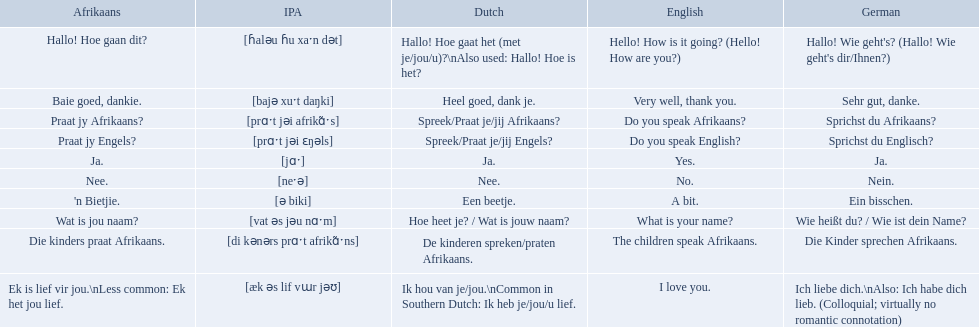What are the afrikaans phrases? Hallo! Hoe gaan dit?, Baie goed, dankie., Praat jy Afrikaans?, Praat jy Engels?, Ja., Nee., 'n Bietjie., Wat is jou naam?, Die kinders praat Afrikaans., Ek is lief vir jou.\nLess common: Ek het jou lief. For die kinders praat afrikaans, what are the translations? De kinderen spreken/praten Afrikaans., The children speak Afrikaans., Die Kinder sprechen Afrikaans. Which one is the german translation? Die Kinder sprechen Afrikaans. What are the listed afrikaans phrases? Hallo! Hoe gaan dit?, Baie goed, dankie., Praat jy Afrikaans?, Praat jy Engels?, Ja., Nee., 'n Bietjie., Wat is jou naam?, Die kinders praat Afrikaans., Ek is lief vir jou.\nLess common: Ek het jou lief. Which is die kinders praat afrikaans? Die kinders praat Afrikaans. What is its german translation? Die Kinder sprechen Afrikaans. In german how do you say do you speak afrikaans? Sprichst du Afrikaans?. How do you say it in afrikaans? Praat jy Afrikaans?. What are all of the afrikaans phrases shown in the table? Hallo! Hoe gaan dit?, Baie goed, dankie., Praat jy Afrikaans?, Praat jy Engels?, Ja., Nee., 'n Bietjie., Wat is jou naam?, Die kinders praat Afrikaans., Ek is lief vir jou.\nLess common: Ek het jou lief. Of those, which translates into english as do you speak afrikaans?? Praat jy Afrikaans?. How do you say hello! how is it going? in afrikaans? Hallo! Hoe gaan dit?. How do you say very well, thank you in afrikaans? Baie goed, dankie. How would you say do you speak afrikaans? in afrikaans? Praat jy Afrikaans?. Which phrases are said in africaans? Hallo! Hoe gaan dit?, Baie goed, dankie., Praat jy Afrikaans?, Praat jy Engels?, Ja., Nee., 'n Bietjie., Wat is jou naam?, Die kinders praat Afrikaans., Ek is lief vir jou.\nLess common: Ek het jou lief. Which of these mean how do you speak afrikaans? Praat jy Afrikaans?. How do you articulate "do you speak afrikaans? Sprichst du Afrikaans?. " in german and how is it communicated in afrikaans? Praat jy Afrikaans?. What phrases are uttered in afrikaans? Hallo! Hoe gaan dit?, Baie goed, dankie., Praat jy Afrikaans?, Praat jy Engels?, Ja., Nee., 'n Bietjie., Wat is jou naam?, Die kinders praat Afrikaans., Ek is lief vir jou.\nLess common: Ek het jou lief. Which among these imply how to converse in afrikaans? Praat jy Afrikaans?. What are the itemized afrikaans sayings? Hallo! Hoe gaan dit?, Baie goed, dankie., Praat jy Afrikaans?, Praat jy Engels?, Ja., Nee., 'n Bietjie., Wat is jou naam?, Die kinders praat Afrikaans., Ek is lief vir jou.\nLess common: Ek het jou lief. Which one aligns with "die kinders praat afrikaans"? Die kinders praat Afrikaans. What is its german rendition? Die Kinder sprechen Afrikaans. How can you express the sentence "the children speak afrikaans" in afrikaans? Die kinders praat Afrikaans. How can you express the aforementioned sentence in german? Die Kinder sprechen Afrikaans. How do you convey "do you speak afrikaans? Sprichst du Afrikaans?. " in german, and what is the afrikaans phrase for it? Praat jy Afrikaans?. How can you convey "do you speak english" in german? Sprichst du Englisch?. Additionally, how to communicate "do you speak afrikaans" in afrikaans? Praat jy Afrikaans?. How do you phrase "do you speak english" in german? Sprichst du Englisch?. Moreover, how to articulate "do you speak afrikaans" in afrikaans? Praat jy Afrikaans?. What afrikaans phrases exist? Hallo! Hoe gaan dit?, Baie goed, dankie., Praat jy Afrikaans?, Praat jy Engels?, Ja., Nee., 'n Bietjie., Wat is jou naam?, Die kinders praat Afrikaans., Ek is lief vir jou.\nLess common: Ek het jou lief. Regarding "die kinders praat afrikaans," what translations can be provided? De kinderen spreken/praten Afrikaans., The children speak Afrikaans., Die Kinder sprechen Afrikaans. Which translation is in german? Die Kinder sprechen Afrikaans. What are the given afrikaans sayings? Hallo! Hoe gaan dit?, Baie goed, dankie., Praat jy Afrikaans?, Praat jy Engels?, Ja., Nee., 'n Bietjie., Wat is jou naam?, Die kinders praat Afrikaans., Ek is lief vir jou.\nLess common: Ek het jou lief. Which one means "die kinders praat afrikaans"? Die kinders praat Afrikaans. What is this phrase translated to in german? Die Kinder sprechen Afrikaans. What afrikaans phrases are provided? Hallo! Hoe gaan dit?, Baie goed, dankie., Praat jy Afrikaans?, Praat jy Engels?, Ja., Nee., 'n Bietjie., Wat is jou naam?, Die kinders praat Afrikaans., Ek is lief vir jou.\nLess common: Ek het jou lief. Which one corresponds to "die kinders praat afrikaans"? Die kinders praat Afrikaans. What would be its translation in german? Die Kinder sprechen Afrikaans. In german, how is "do you speak afrikaans? Sprichst du Afrikaans?. " translated, and how is it expressed in afrikaans itself? Praat jy Afrikaans?. What is the translation of "do you speak afrikaans? Sprichst du Afrikaans?. " in german and afrikaans languages? Praat jy Afrikaans?. How can one ask "do you speak afrikaans? Sprichst du Afrikaans?. " in both german and afrikaans? Praat jy Afrikaans?. Can you tell me the way to say hello and ask about someone's well-being in afrikaans? Hallo! Hoe gaan dit?. How would you respond affirmatively and express gratitude in afrikaans? Baie goed, dankie. How do you ask someone if they can speak afrikaans, in afrikaans? Praat jy Afrikaans?. 